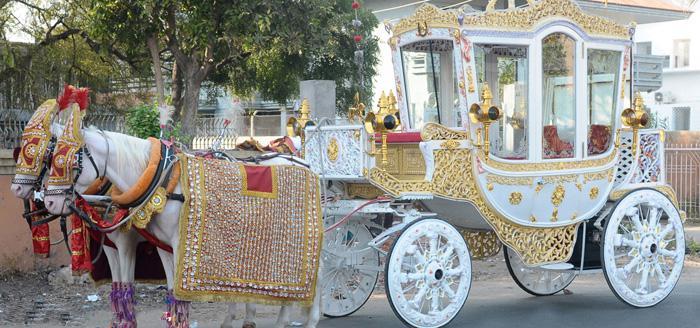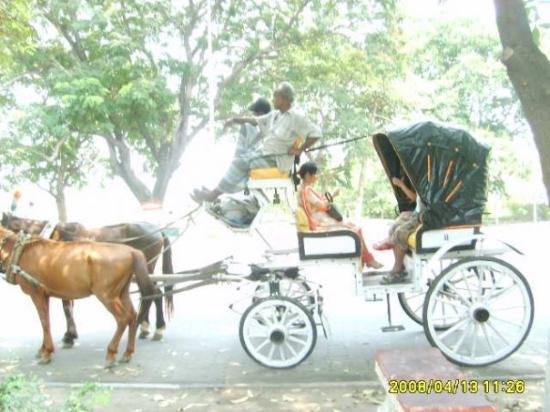The first image is the image on the left, the second image is the image on the right. Assess this claim about the two images: "A car is behind a horse carriage.". Correct or not? Answer yes or no. No. The first image is the image on the left, the second image is the image on the right. Examine the images to the left and right. Is the description "An image shows a leftward-headed wagon with ornate white wheels, pulled by at least one white horse." accurate? Answer yes or no. Yes. 